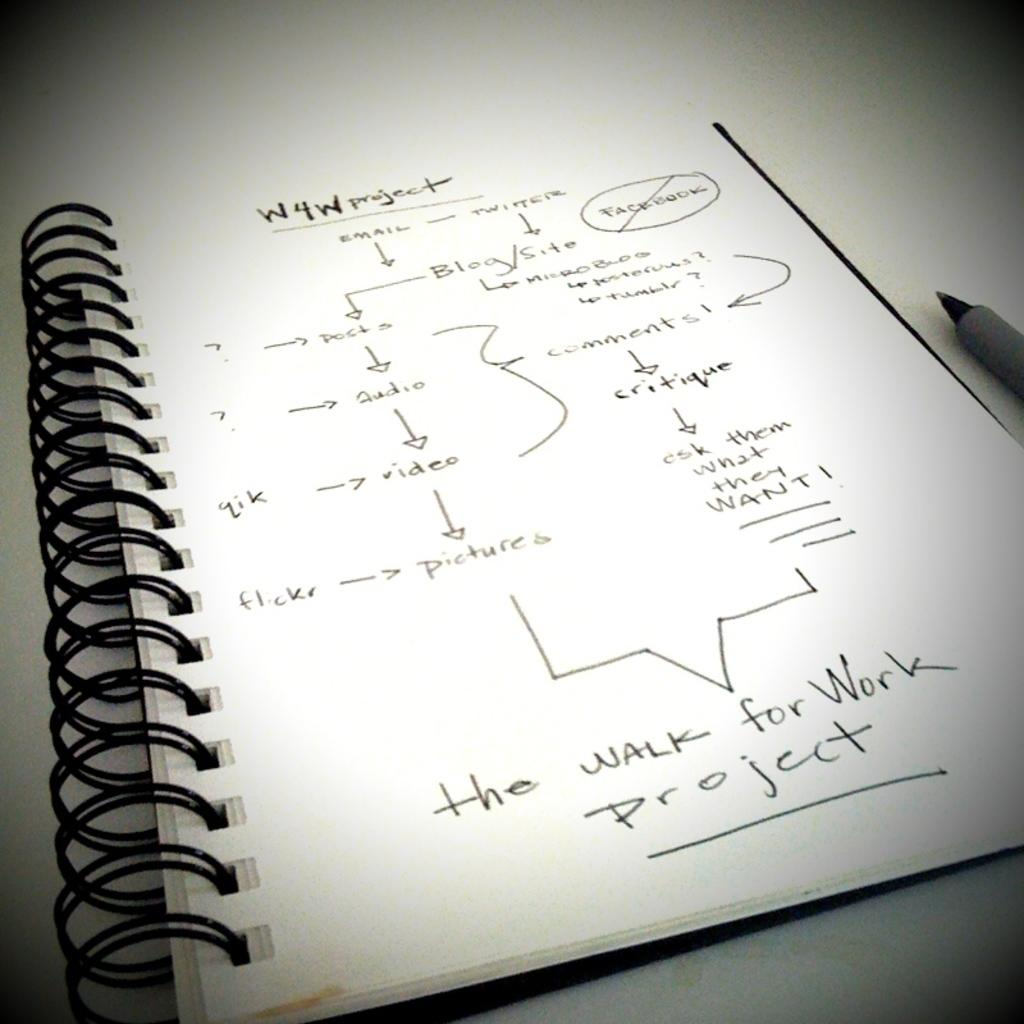<image>
Relay a brief, clear account of the picture shown. a notebook that has the walk for work written in it 